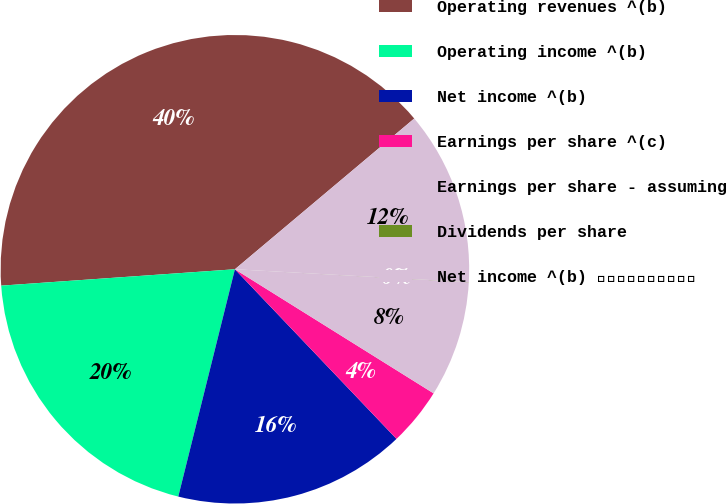Convert chart. <chart><loc_0><loc_0><loc_500><loc_500><pie_chart><fcel>Operating revenues ^(b)<fcel>Operating income ^(b)<fcel>Net income ^(b)<fcel>Earnings per share ^(c)<fcel>Earnings per share - assuming<fcel>Dividends per share<fcel>Net income ^(b) ⎯⎯⎯⎯⎯⎯⎯⎯⎯⎯<nl><fcel>39.99%<fcel>20.0%<fcel>16.0%<fcel>4.0%<fcel>8.0%<fcel>0.01%<fcel>12.0%<nl></chart> 